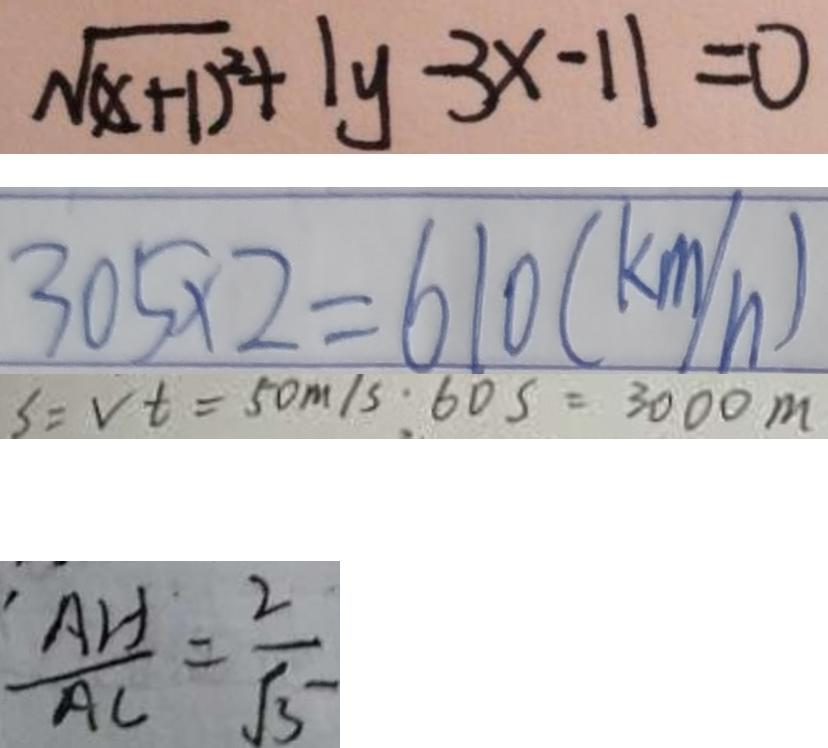Convert formula to latex. <formula><loc_0><loc_0><loc_500><loc_500>\sqrt { ( x + 1 ) ^ { 2 } } + \vert y - 3 x - 1 \vert = 0 
 3 0 5 \times 2 = 6 1 0 ( k m / h ) 
 S = V t = 5 0 m / s : 6 0 S = 3 0 0 0 m 
 \frac { A H } { A C } = \frac { 2 } { \sqrt { 3 } }</formula> 